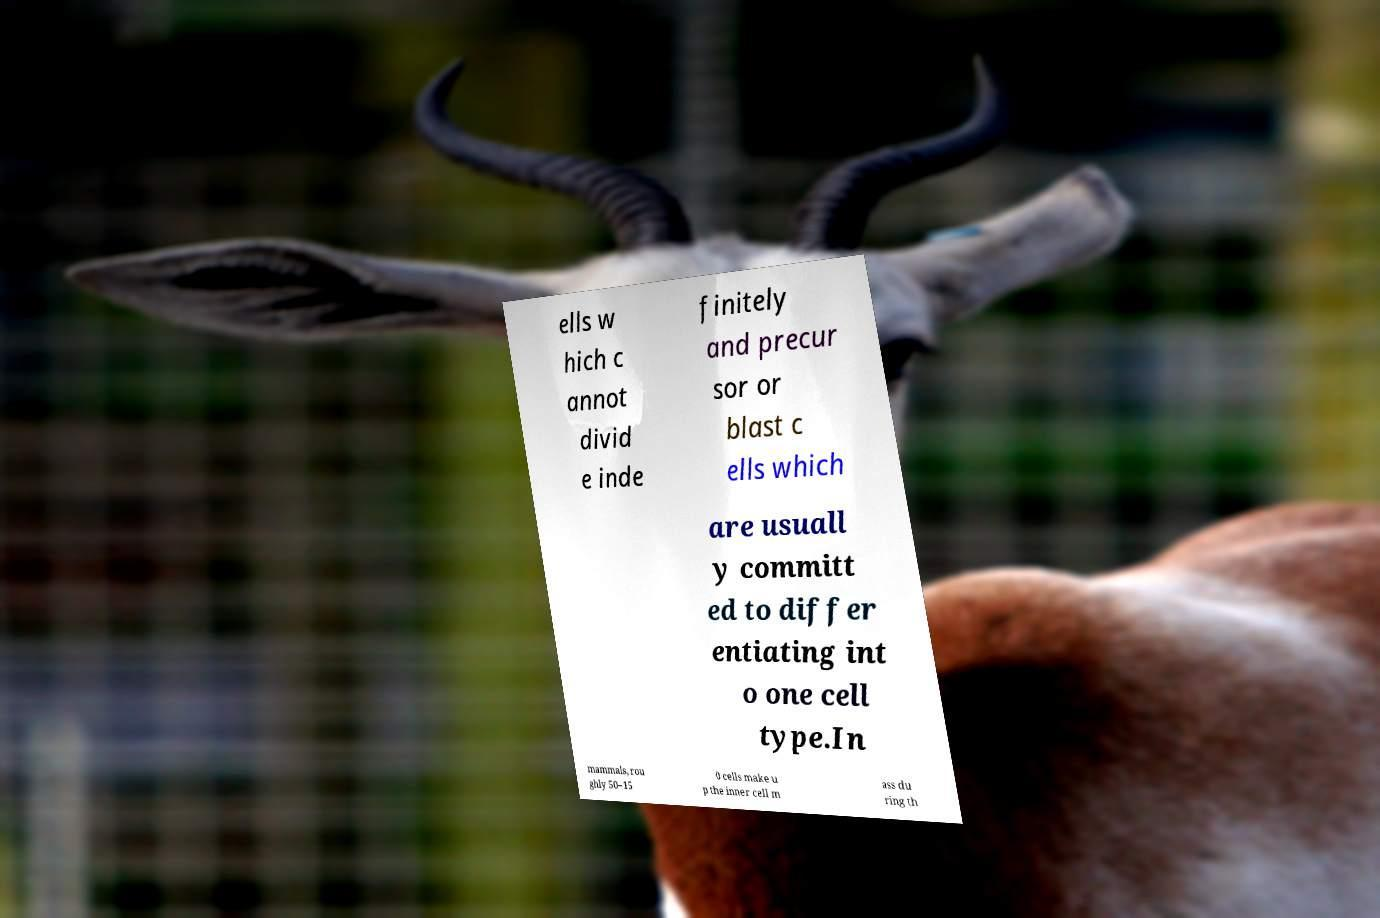There's text embedded in this image that I need extracted. Can you transcribe it verbatim? ells w hich c annot divid e inde finitely and precur sor or blast c ells which are usuall y committ ed to differ entiating int o one cell type.In mammals, rou ghly 50–15 0 cells make u p the inner cell m ass du ring th 